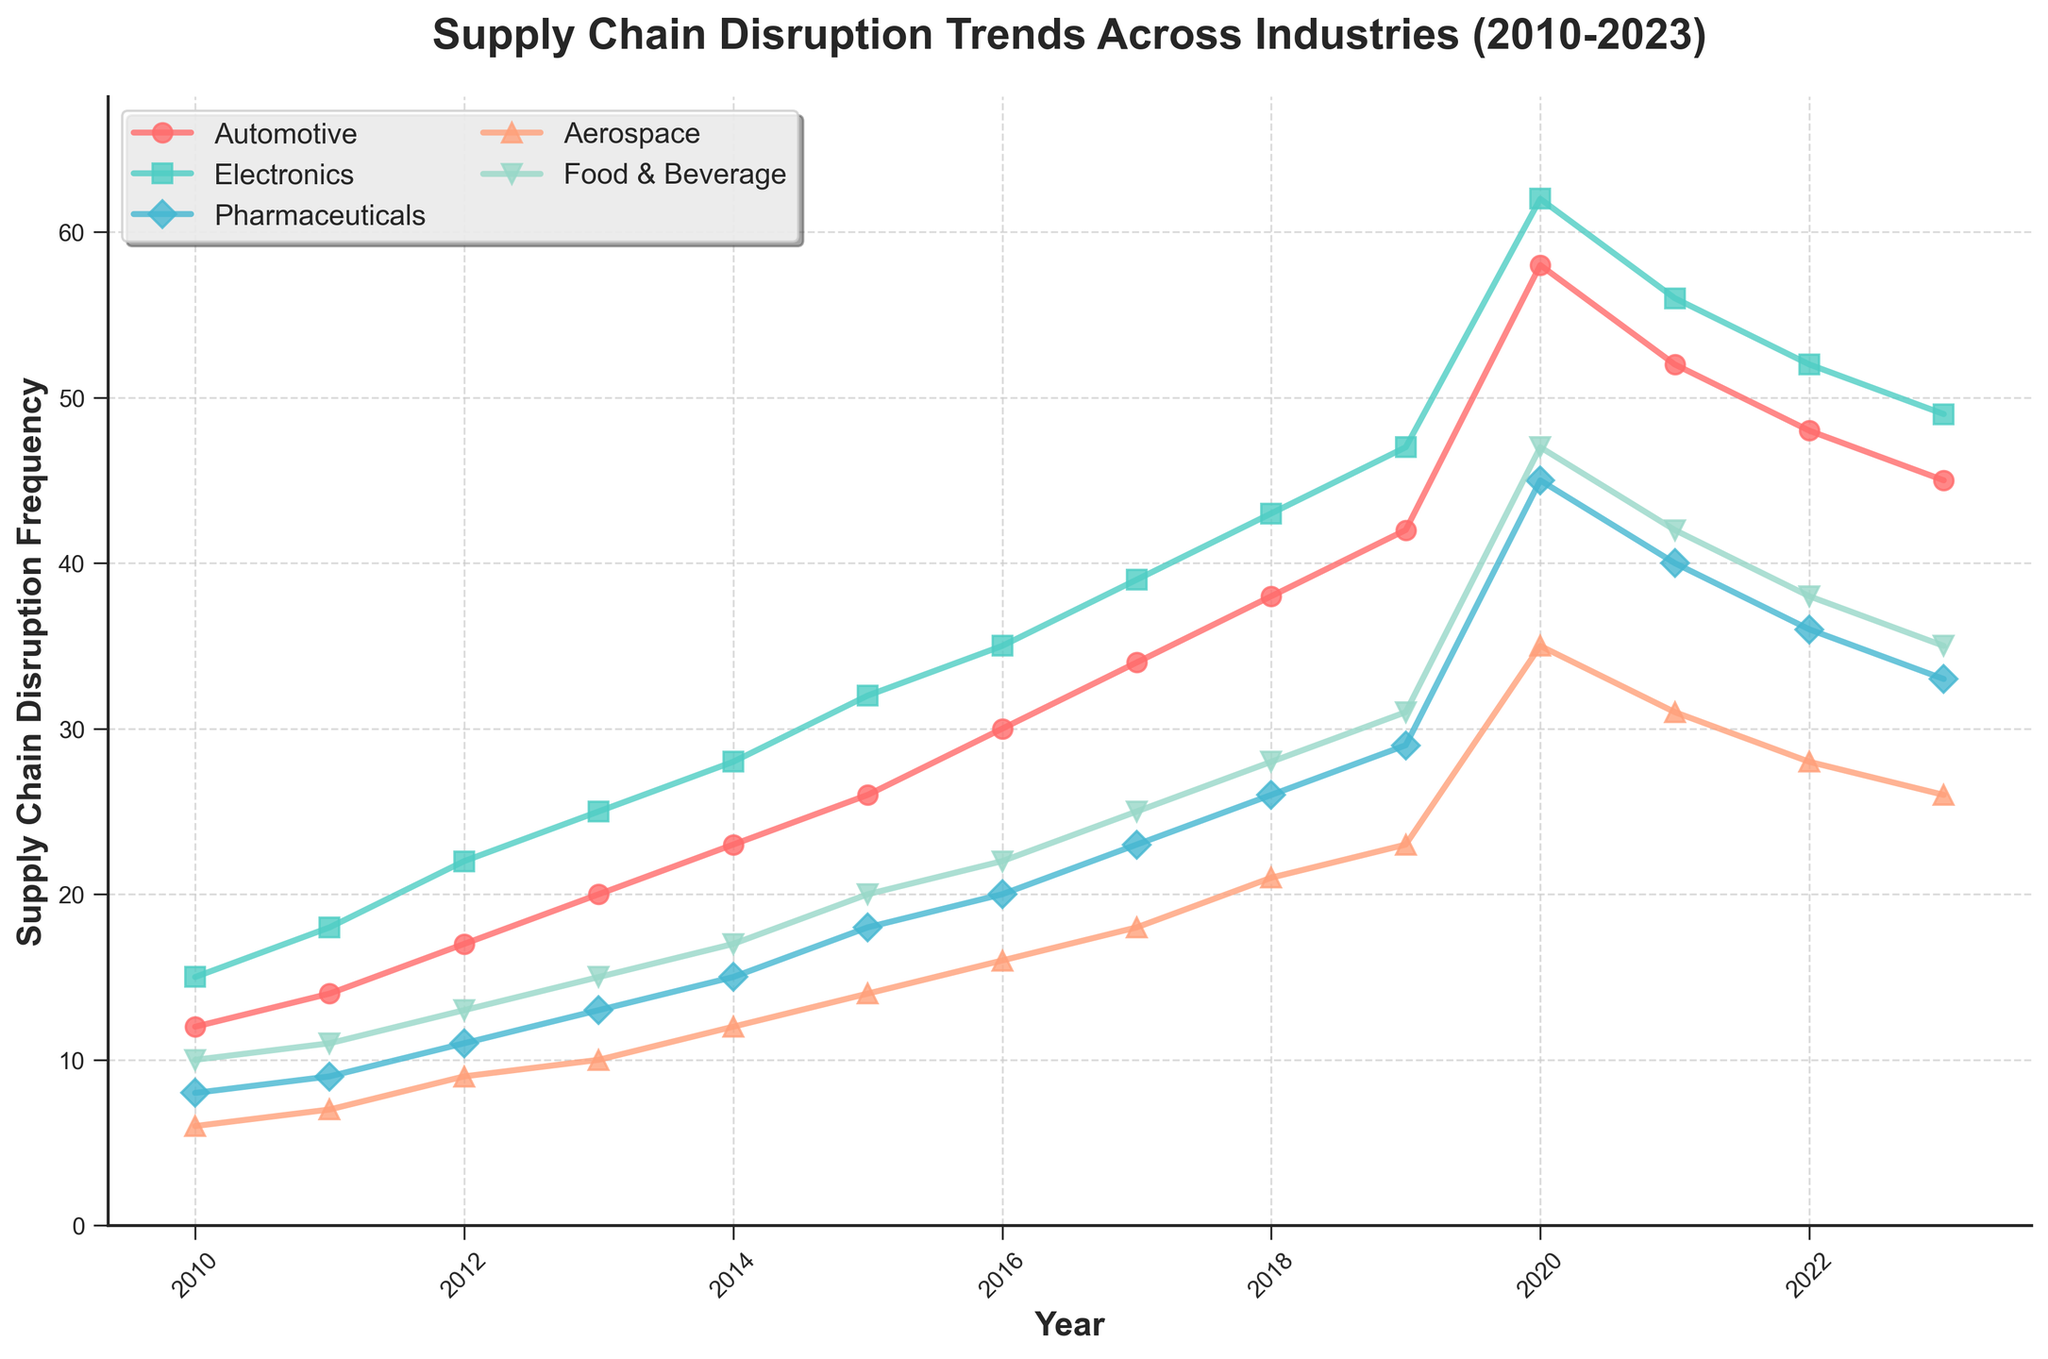What is the general trend of supply chain disruptions in the Automotive industry from 2010 to 2023? The Automotive industry shows an overall increasing trend in supply chain disruption frequency from 2010 to 2023, reaching a peak in 2020 and then slightly decreasing.
Answer: Increasing trend with a peak in 2020 Which industry shows the highest frequency of supply chain disruptions in 2020? Looking at the values for 2020, the Electronics industry has the highest disruption frequency.
Answer: Electronics By how much did the supply chain disruption frequency in the Food & Beverage industry increase from 2015 to 2020? The frequency in the Food & Beverage industry was 20 in 2015 and increased to 47 in 2020. The increase is 47 - 20 = 27.
Answer: 27 Between which consecutive years did the Pharmaceuticals industry see the highest increase in disruption frequency? The Pharmaceuticals industry saw its highest increase between 2019 and 2020, where the frequency went from 29 to 45, an increase of 16.
Answer: 2019 to 2020 What is the average supply chain disruption frequency for the Aerospace industry between 2010 and 2023? Adding up the Aerospace disruption frequencies for each year (6 + 7 + 9 + 10 + 12 + 14 + 16 + 18 + 21 + 23 + 35 + 31 + 28 + 26) and dividing by the total number of years (14) gives 256 / 14 ≈ 18.29.
Answer: 18.29 Compare the disruption trends in the Electronics and Aerospace industries from 2010 to 2023. Which statement is true? Both industries show an increasing trend up to 2020, but Electronics has a sharper increase. While both decrease after 2020, Electronics' frequency remains higher.
Answer: Electronics shows a sharper increase and remains higher What visual element indicates the highest disruption frequency in the Pharmaceuticals industry? The highest frequency in the Pharmaceuticals industry is marked by a diamond marker at its peak in 2020.
Answer: Diamond marker in 2020 By how much did the disruption frequency in the Automotive industry change from its peak in 2020 to 2023? The peak in 2020 for the Automotive industry was 58, decreasing to 45 in 2023. The change is 58 - 45 = 13.
Answer: 13 Which two industries have the closest disruption frequencies in 2023? Automotive with 45 and Food & Beverage with 35 have the closest frequencies to each other. The other pairs have larger differences.
Answer: Automotive and Electronics 